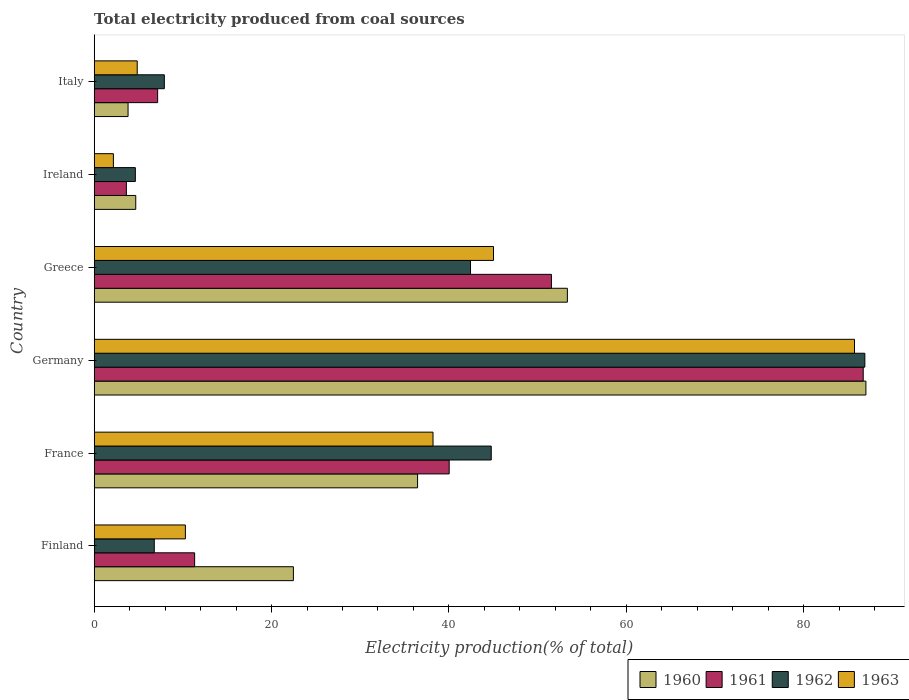Are the number of bars per tick equal to the number of legend labels?
Your answer should be very brief. Yes. How many bars are there on the 5th tick from the bottom?
Ensure brevity in your answer.  4. What is the total electricity produced in 1963 in Finland?
Your answer should be compact. 10.28. Across all countries, what is the maximum total electricity produced in 1963?
Offer a very short reply. 85.74. Across all countries, what is the minimum total electricity produced in 1961?
Make the answer very short. 3.63. In which country was the total electricity produced in 1963 minimum?
Make the answer very short. Ireland. What is the total total electricity produced in 1962 in the graph?
Ensure brevity in your answer.  193.45. What is the difference between the total electricity produced in 1960 in Finland and that in France?
Your answer should be very brief. -14. What is the difference between the total electricity produced in 1960 in Ireland and the total electricity produced in 1962 in Germany?
Offer a very short reply. -82.22. What is the average total electricity produced in 1962 per country?
Your answer should be compact. 32.24. What is the difference between the total electricity produced in 1962 and total electricity produced in 1961 in Greece?
Make the answer very short. -9.12. In how many countries, is the total electricity produced in 1960 greater than 80 %?
Make the answer very short. 1. What is the ratio of the total electricity produced in 1960 in Finland to that in Italy?
Offer a very short reply. 5.88. Is the total electricity produced in 1963 in Germany less than that in Ireland?
Provide a short and direct response. No. What is the difference between the highest and the second highest total electricity produced in 1961?
Provide a succinct answer. 35.16. What is the difference between the highest and the lowest total electricity produced in 1960?
Keep it short and to the point. 83.21. Is it the case that in every country, the sum of the total electricity produced in 1960 and total electricity produced in 1963 is greater than the total electricity produced in 1961?
Keep it short and to the point. Yes. How many bars are there?
Your answer should be compact. 24. Are all the bars in the graph horizontal?
Keep it short and to the point. Yes. Are the values on the major ticks of X-axis written in scientific E-notation?
Keep it short and to the point. No. Does the graph contain any zero values?
Keep it short and to the point. No. Does the graph contain grids?
Your answer should be very brief. No. Where does the legend appear in the graph?
Give a very brief answer. Bottom right. What is the title of the graph?
Provide a succinct answer. Total electricity produced from coal sources. Does "1976" appear as one of the legend labels in the graph?
Offer a terse response. No. What is the Electricity production(% of total) in 1960 in Finland?
Provide a succinct answer. 22.46. What is the Electricity production(% of total) in 1961 in Finland?
Offer a terse response. 11.33. What is the Electricity production(% of total) of 1962 in Finland?
Offer a terse response. 6.78. What is the Electricity production(% of total) in 1963 in Finland?
Make the answer very short. 10.28. What is the Electricity production(% of total) of 1960 in France?
Make the answer very short. 36.47. What is the Electricity production(% of total) in 1961 in France?
Provide a short and direct response. 40.03. What is the Electricity production(% of total) of 1962 in France?
Your answer should be very brief. 44.78. What is the Electricity production(% of total) of 1963 in France?
Ensure brevity in your answer.  38.21. What is the Electricity production(% of total) of 1960 in Germany?
Your response must be concise. 87.03. What is the Electricity production(% of total) in 1961 in Germany?
Provide a short and direct response. 86.73. What is the Electricity production(% of total) of 1962 in Germany?
Offer a very short reply. 86.91. What is the Electricity production(% of total) of 1963 in Germany?
Ensure brevity in your answer.  85.74. What is the Electricity production(% of total) in 1960 in Greece?
Give a very brief answer. 53.36. What is the Electricity production(% of total) in 1961 in Greece?
Offer a terse response. 51.56. What is the Electricity production(% of total) of 1962 in Greece?
Your answer should be very brief. 42.44. What is the Electricity production(% of total) in 1963 in Greece?
Your answer should be very brief. 45.03. What is the Electricity production(% of total) in 1960 in Ireland?
Offer a very short reply. 4.69. What is the Electricity production(% of total) of 1961 in Ireland?
Your response must be concise. 3.63. What is the Electricity production(% of total) in 1962 in Ireland?
Give a very brief answer. 4.64. What is the Electricity production(% of total) in 1963 in Ireland?
Offer a terse response. 2.16. What is the Electricity production(% of total) of 1960 in Italy?
Offer a very short reply. 3.82. What is the Electricity production(% of total) in 1961 in Italy?
Keep it short and to the point. 7.15. What is the Electricity production(% of total) of 1962 in Italy?
Your answer should be compact. 7.91. What is the Electricity production(% of total) in 1963 in Italy?
Provide a succinct answer. 4.85. Across all countries, what is the maximum Electricity production(% of total) of 1960?
Offer a very short reply. 87.03. Across all countries, what is the maximum Electricity production(% of total) of 1961?
Offer a terse response. 86.73. Across all countries, what is the maximum Electricity production(% of total) of 1962?
Keep it short and to the point. 86.91. Across all countries, what is the maximum Electricity production(% of total) in 1963?
Your answer should be compact. 85.74. Across all countries, what is the minimum Electricity production(% of total) in 1960?
Your answer should be compact. 3.82. Across all countries, what is the minimum Electricity production(% of total) of 1961?
Your answer should be compact. 3.63. Across all countries, what is the minimum Electricity production(% of total) of 1962?
Keep it short and to the point. 4.64. Across all countries, what is the minimum Electricity production(% of total) in 1963?
Your answer should be very brief. 2.16. What is the total Electricity production(% of total) of 1960 in the graph?
Your answer should be compact. 207.83. What is the total Electricity production(% of total) of 1961 in the graph?
Your answer should be compact. 200.43. What is the total Electricity production(% of total) in 1962 in the graph?
Give a very brief answer. 193.45. What is the total Electricity production(% of total) in 1963 in the graph?
Offer a terse response. 186.28. What is the difference between the Electricity production(% of total) of 1960 in Finland and that in France?
Provide a succinct answer. -14.01. What is the difference between the Electricity production(% of total) in 1961 in Finland and that in France?
Ensure brevity in your answer.  -28.71. What is the difference between the Electricity production(% of total) in 1962 in Finland and that in France?
Provide a succinct answer. -38. What is the difference between the Electricity production(% of total) of 1963 in Finland and that in France?
Offer a very short reply. -27.93. What is the difference between the Electricity production(% of total) in 1960 in Finland and that in Germany?
Provide a short and direct response. -64.57. What is the difference between the Electricity production(% of total) of 1961 in Finland and that in Germany?
Ensure brevity in your answer.  -75.4. What is the difference between the Electricity production(% of total) of 1962 in Finland and that in Germany?
Give a very brief answer. -80.13. What is the difference between the Electricity production(% of total) of 1963 in Finland and that in Germany?
Your answer should be very brief. -75.46. What is the difference between the Electricity production(% of total) in 1960 in Finland and that in Greece?
Provide a short and direct response. -30.9. What is the difference between the Electricity production(% of total) of 1961 in Finland and that in Greece?
Ensure brevity in your answer.  -40.24. What is the difference between the Electricity production(% of total) of 1962 in Finland and that in Greece?
Offer a very short reply. -35.66. What is the difference between the Electricity production(% of total) of 1963 in Finland and that in Greece?
Your response must be concise. -34.75. What is the difference between the Electricity production(% of total) in 1960 in Finland and that in Ireland?
Offer a very short reply. 17.78. What is the difference between the Electricity production(% of total) in 1961 in Finland and that in Ireland?
Offer a terse response. 7.7. What is the difference between the Electricity production(% of total) in 1962 in Finland and that in Ireland?
Provide a short and direct response. 2.13. What is the difference between the Electricity production(% of total) of 1963 in Finland and that in Ireland?
Provide a succinct answer. 8.12. What is the difference between the Electricity production(% of total) of 1960 in Finland and that in Italy?
Your answer should be very brief. 18.65. What is the difference between the Electricity production(% of total) of 1961 in Finland and that in Italy?
Provide a short and direct response. 4.17. What is the difference between the Electricity production(% of total) of 1962 in Finland and that in Italy?
Your answer should be very brief. -1.13. What is the difference between the Electricity production(% of total) of 1963 in Finland and that in Italy?
Your response must be concise. 5.43. What is the difference between the Electricity production(% of total) in 1960 in France and that in Germany?
Provide a succinct answer. -50.56. What is the difference between the Electricity production(% of total) in 1961 in France and that in Germany?
Ensure brevity in your answer.  -46.69. What is the difference between the Electricity production(% of total) in 1962 in France and that in Germany?
Keep it short and to the point. -42.13. What is the difference between the Electricity production(% of total) in 1963 in France and that in Germany?
Keep it short and to the point. -47.53. What is the difference between the Electricity production(% of total) in 1960 in France and that in Greece?
Your answer should be very brief. -16.89. What is the difference between the Electricity production(% of total) in 1961 in France and that in Greece?
Your answer should be compact. -11.53. What is the difference between the Electricity production(% of total) in 1962 in France and that in Greece?
Your answer should be compact. 2.34. What is the difference between the Electricity production(% of total) of 1963 in France and that in Greece?
Keep it short and to the point. -6.82. What is the difference between the Electricity production(% of total) of 1960 in France and that in Ireland?
Provide a short and direct response. 31.78. What is the difference between the Electricity production(% of total) in 1961 in France and that in Ireland?
Offer a very short reply. 36.41. What is the difference between the Electricity production(% of total) of 1962 in France and that in Ireland?
Your response must be concise. 40.14. What is the difference between the Electricity production(% of total) of 1963 in France and that in Ireland?
Ensure brevity in your answer.  36.05. What is the difference between the Electricity production(% of total) of 1960 in France and that in Italy?
Keep it short and to the point. 32.65. What is the difference between the Electricity production(% of total) in 1961 in France and that in Italy?
Your answer should be compact. 32.88. What is the difference between the Electricity production(% of total) in 1962 in France and that in Italy?
Give a very brief answer. 36.87. What is the difference between the Electricity production(% of total) in 1963 in France and that in Italy?
Your answer should be very brief. 33.36. What is the difference between the Electricity production(% of total) of 1960 in Germany and that in Greece?
Your answer should be very brief. 33.67. What is the difference between the Electricity production(% of total) in 1961 in Germany and that in Greece?
Offer a terse response. 35.16. What is the difference between the Electricity production(% of total) in 1962 in Germany and that in Greece?
Your answer should be compact. 44.47. What is the difference between the Electricity production(% of total) in 1963 in Germany and that in Greece?
Keep it short and to the point. 40.71. What is the difference between the Electricity production(% of total) in 1960 in Germany and that in Ireland?
Ensure brevity in your answer.  82.34. What is the difference between the Electricity production(% of total) in 1961 in Germany and that in Ireland?
Ensure brevity in your answer.  83.1. What is the difference between the Electricity production(% of total) of 1962 in Germany and that in Ireland?
Provide a short and direct response. 82.27. What is the difference between the Electricity production(% of total) in 1963 in Germany and that in Ireland?
Provide a short and direct response. 83.58. What is the difference between the Electricity production(% of total) in 1960 in Germany and that in Italy?
Ensure brevity in your answer.  83.21. What is the difference between the Electricity production(% of total) in 1961 in Germany and that in Italy?
Your answer should be very brief. 79.57. What is the difference between the Electricity production(% of total) of 1962 in Germany and that in Italy?
Make the answer very short. 79. What is the difference between the Electricity production(% of total) of 1963 in Germany and that in Italy?
Provide a succinct answer. 80.89. What is the difference between the Electricity production(% of total) in 1960 in Greece and that in Ireland?
Your response must be concise. 48.68. What is the difference between the Electricity production(% of total) of 1961 in Greece and that in Ireland?
Keep it short and to the point. 47.93. What is the difference between the Electricity production(% of total) in 1962 in Greece and that in Ireland?
Give a very brief answer. 37.8. What is the difference between the Electricity production(% of total) in 1963 in Greece and that in Ireland?
Offer a very short reply. 42.87. What is the difference between the Electricity production(% of total) in 1960 in Greece and that in Italy?
Your answer should be compact. 49.54. What is the difference between the Electricity production(% of total) in 1961 in Greece and that in Italy?
Give a very brief answer. 44.41. What is the difference between the Electricity production(% of total) in 1962 in Greece and that in Italy?
Your answer should be compact. 34.53. What is the difference between the Electricity production(% of total) in 1963 in Greece and that in Italy?
Your answer should be compact. 40.18. What is the difference between the Electricity production(% of total) of 1960 in Ireland and that in Italy?
Give a very brief answer. 0.87. What is the difference between the Electricity production(% of total) in 1961 in Ireland and that in Italy?
Provide a short and direct response. -3.53. What is the difference between the Electricity production(% of total) in 1962 in Ireland and that in Italy?
Offer a terse response. -3.27. What is the difference between the Electricity production(% of total) in 1963 in Ireland and that in Italy?
Offer a terse response. -2.69. What is the difference between the Electricity production(% of total) of 1960 in Finland and the Electricity production(% of total) of 1961 in France?
Your answer should be very brief. -17.57. What is the difference between the Electricity production(% of total) in 1960 in Finland and the Electricity production(% of total) in 1962 in France?
Your response must be concise. -22.31. What is the difference between the Electricity production(% of total) in 1960 in Finland and the Electricity production(% of total) in 1963 in France?
Your answer should be compact. -15.75. What is the difference between the Electricity production(% of total) in 1961 in Finland and the Electricity production(% of total) in 1962 in France?
Your response must be concise. -33.45. What is the difference between the Electricity production(% of total) of 1961 in Finland and the Electricity production(% of total) of 1963 in France?
Provide a succinct answer. -26.88. What is the difference between the Electricity production(% of total) in 1962 in Finland and the Electricity production(% of total) in 1963 in France?
Offer a very short reply. -31.44. What is the difference between the Electricity production(% of total) of 1960 in Finland and the Electricity production(% of total) of 1961 in Germany?
Offer a terse response. -64.26. What is the difference between the Electricity production(% of total) in 1960 in Finland and the Electricity production(% of total) in 1962 in Germany?
Give a very brief answer. -64.45. What is the difference between the Electricity production(% of total) in 1960 in Finland and the Electricity production(% of total) in 1963 in Germany?
Give a very brief answer. -63.28. What is the difference between the Electricity production(% of total) in 1961 in Finland and the Electricity production(% of total) in 1962 in Germany?
Provide a short and direct response. -75.58. What is the difference between the Electricity production(% of total) of 1961 in Finland and the Electricity production(% of total) of 1963 in Germany?
Your response must be concise. -74.41. What is the difference between the Electricity production(% of total) in 1962 in Finland and the Electricity production(% of total) in 1963 in Germany?
Your response must be concise. -78.97. What is the difference between the Electricity production(% of total) in 1960 in Finland and the Electricity production(% of total) in 1961 in Greece?
Your response must be concise. -29.1. What is the difference between the Electricity production(% of total) of 1960 in Finland and the Electricity production(% of total) of 1962 in Greece?
Offer a very short reply. -19.98. What is the difference between the Electricity production(% of total) in 1960 in Finland and the Electricity production(% of total) in 1963 in Greece?
Your answer should be very brief. -22.57. What is the difference between the Electricity production(% of total) of 1961 in Finland and the Electricity production(% of total) of 1962 in Greece?
Offer a terse response. -31.11. What is the difference between the Electricity production(% of total) in 1961 in Finland and the Electricity production(% of total) in 1963 in Greece?
Your answer should be very brief. -33.7. What is the difference between the Electricity production(% of total) of 1962 in Finland and the Electricity production(% of total) of 1963 in Greece?
Give a very brief answer. -38.26. What is the difference between the Electricity production(% of total) in 1960 in Finland and the Electricity production(% of total) in 1961 in Ireland?
Your answer should be very brief. 18.84. What is the difference between the Electricity production(% of total) in 1960 in Finland and the Electricity production(% of total) in 1962 in Ireland?
Your answer should be compact. 17.82. What is the difference between the Electricity production(% of total) of 1960 in Finland and the Electricity production(% of total) of 1963 in Ireland?
Give a very brief answer. 20.3. What is the difference between the Electricity production(% of total) in 1961 in Finland and the Electricity production(% of total) in 1962 in Ireland?
Your answer should be very brief. 6.69. What is the difference between the Electricity production(% of total) in 1961 in Finland and the Electricity production(% of total) in 1963 in Ireland?
Provide a short and direct response. 9.16. What is the difference between the Electricity production(% of total) in 1962 in Finland and the Electricity production(% of total) in 1963 in Ireland?
Your response must be concise. 4.61. What is the difference between the Electricity production(% of total) of 1960 in Finland and the Electricity production(% of total) of 1961 in Italy?
Your answer should be very brief. 15.31. What is the difference between the Electricity production(% of total) of 1960 in Finland and the Electricity production(% of total) of 1962 in Italy?
Make the answer very short. 14.55. What is the difference between the Electricity production(% of total) of 1960 in Finland and the Electricity production(% of total) of 1963 in Italy?
Your response must be concise. 17.61. What is the difference between the Electricity production(% of total) of 1961 in Finland and the Electricity production(% of total) of 1962 in Italy?
Ensure brevity in your answer.  3.42. What is the difference between the Electricity production(% of total) of 1961 in Finland and the Electricity production(% of total) of 1963 in Italy?
Give a very brief answer. 6.48. What is the difference between the Electricity production(% of total) in 1962 in Finland and the Electricity production(% of total) in 1963 in Italy?
Provide a succinct answer. 1.92. What is the difference between the Electricity production(% of total) in 1960 in France and the Electricity production(% of total) in 1961 in Germany?
Give a very brief answer. -50.26. What is the difference between the Electricity production(% of total) of 1960 in France and the Electricity production(% of total) of 1962 in Germany?
Your response must be concise. -50.44. What is the difference between the Electricity production(% of total) of 1960 in France and the Electricity production(% of total) of 1963 in Germany?
Ensure brevity in your answer.  -49.27. What is the difference between the Electricity production(% of total) of 1961 in France and the Electricity production(% of total) of 1962 in Germany?
Your answer should be compact. -46.87. What is the difference between the Electricity production(% of total) in 1961 in France and the Electricity production(% of total) in 1963 in Germany?
Provide a succinct answer. -45.71. What is the difference between the Electricity production(% of total) in 1962 in France and the Electricity production(% of total) in 1963 in Germany?
Keep it short and to the point. -40.97. What is the difference between the Electricity production(% of total) of 1960 in France and the Electricity production(% of total) of 1961 in Greece?
Offer a very short reply. -15.09. What is the difference between the Electricity production(% of total) in 1960 in France and the Electricity production(% of total) in 1962 in Greece?
Offer a terse response. -5.97. What is the difference between the Electricity production(% of total) in 1960 in France and the Electricity production(% of total) in 1963 in Greece?
Provide a succinct answer. -8.56. What is the difference between the Electricity production(% of total) of 1961 in France and the Electricity production(% of total) of 1962 in Greece?
Provide a succinct answer. -2.41. What is the difference between the Electricity production(% of total) in 1961 in France and the Electricity production(% of total) in 1963 in Greece?
Offer a very short reply. -5. What is the difference between the Electricity production(% of total) in 1962 in France and the Electricity production(% of total) in 1963 in Greece?
Ensure brevity in your answer.  -0.25. What is the difference between the Electricity production(% of total) of 1960 in France and the Electricity production(% of total) of 1961 in Ireland?
Provide a short and direct response. 32.84. What is the difference between the Electricity production(% of total) of 1960 in France and the Electricity production(% of total) of 1962 in Ireland?
Your response must be concise. 31.83. What is the difference between the Electricity production(% of total) of 1960 in France and the Electricity production(% of total) of 1963 in Ireland?
Your response must be concise. 34.3. What is the difference between the Electricity production(% of total) in 1961 in France and the Electricity production(% of total) in 1962 in Ireland?
Provide a short and direct response. 35.39. What is the difference between the Electricity production(% of total) of 1961 in France and the Electricity production(% of total) of 1963 in Ireland?
Ensure brevity in your answer.  37.87. What is the difference between the Electricity production(% of total) in 1962 in France and the Electricity production(% of total) in 1963 in Ireland?
Make the answer very short. 42.61. What is the difference between the Electricity production(% of total) of 1960 in France and the Electricity production(% of total) of 1961 in Italy?
Offer a terse response. 29.31. What is the difference between the Electricity production(% of total) of 1960 in France and the Electricity production(% of total) of 1962 in Italy?
Give a very brief answer. 28.56. What is the difference between the Electricity production(% of total) in 1960 in France and the Electricity production(% of total) in 1963 in Italy?
Make the answer very short. 31.62. What is the difference between the Electricity production(% of total) of 1961 in France and the Electricity production(% of total) of 1962 in Italy?
Offer a terse response. 32.13. What is the difference between the Electricity production(% of total) in 1961 in France and the Electricity production(% of total) in 1963 in Italy?
Offer a terse response. 35.18. What is the difference between the Electricity production(% of total) of 1962 in France and the Electricity production(% of total) of 1963 in Italy?
Your response must be concise. 39.93. What is the difference between the Electricity production(% of total) of 1960 in Germany and the Electricity production(% of total) of 1961 in Greece?
Make the answer very short. 35.47. What is the difference between the Electricity production(% of total) in 1960 in Germany and the Electricity production(% of total) in 1962 in Greece?
Offer a terse response. 44.59. What is the difference between the Electricity production(% of total) of 1960 in Germany and the Electricity production(% of total) of 1963 in Greece?
Keep it short and to the point. 42. What is the difference between the Electricity production(% of total) of 1961 in Germany and the Electricity production(% of total) of 1962 in Greece?
Your response must be concise. 44.29. What is the difference between the Electricity production(% of total) in 1961 in Germany and the Electricity production(% of total) in 1963 in Greece?
Provide a succinct answer. 41.69. What is the difference between the Electricity production(% of total) of 1962 in Germany and the Electricity production(% of total) of 1963 in Greece?
Provide a short and direct response. 41.88. What is the difference between the Electricity production(% of total) in 1960 in Germany and the Electricity production(% of total) in 1961 in Ireland?
Give a very brief answer. 83.4. What is the difference between the Electricity production(% of total) of 1960 in Germany and the Electricity production(% of total) of 1962 in Ireland?
Provide a short and direct response. 82.39. What is the difference between the Electricity production(% of total) in 1960 in Germany and the Electricity production(% of total) in 1963 in Ireland?
Your answer should be very brief. 84.86. What is the difference between the Electricity production(% of total) of 1961 in Germany and the Electricity production(% of total) of 1962 in Ireland?
Your answer should be compact. 82.08. What is the difference between the Electricity production(% of total) in 1961 in Germany and the Electricity production(% of total) in 1963 in Ireland?
Your answer should be compact. 84.56. What is the difference between the Electricity production(% of total) in 1962 in Germany and the Electricity production(% of total) in 1963 in Ireland?
Your response must be concise. 84.74. What is the difference between the Electricity production(% of total) in 1960 in Germany and the Electricity production(% of total) in 1961 in Italy?
Give a very brief answer. 79.87. What is the difference between the Electricity production(% of total) of 1960 in Germany and the Electricity production(% of total) of 1962 in Italy?
Offer a terse response. 79.12. What is the difference between the Electricity production(% of total) of 1960 in Germany and the Electricity production(% of total) of 1963 in Italy?
Ensure brevity in your answer.  82.18. What is the difference between the Electricity production(% of total) in 1961 in Germany and the Electricity production(% of total) in 1962 in Italy?
Your response must be concise. 78.82. What is the difference between the Electricity production(% of total) in 1961 in Germany and the Electricity production(% of total) in 1963 in Italy?
Offer a very short reply. 81.87. What is the difference between the Electricity production(% of total) in 1962 in Germany and the Electricity production(% of total) in 1963 in Italy?
Provide a short and direct response. 82.06. What is the difference between the Electricity production(% of total) of 1960 in Greece and the Electricity production(% of total) of 1961 in Ireland?
Provide a succinct answer. 49.73. What is the difference between the Electricity production(% of total) in 1960 in Greece and the Electricity production(% of total) in 1962 in Ireland?
Make the answer very short. 48.72. What is the difference between the Electricity production(% of total) of 1960 in Greece and the Electricity production(% of total) of 1963 in Ireland?
Provide a short and direct response. 51.2. What is the difference between the Electricity production(% of total) of 1961 in Greece and the Electricity production(% of total) of 1962 in Ireland?
Keep it short and to the point. 46.92. What is the difference between the Electricity production(% of total) in 1961 in Greece and the Electricity production(% of total) in 1963 in Ireland?
Your answer should be very brief. 49.4. What is the difference between the Electricity production(% of total) of 1962 in Greece and the Electricity production(% of total) of 1963 in Ireland?
Provide a short and direct response. 40.27. What is the difference between the Electricity production(% of total) in 1960 in Greece and the Electricity production(% of total) in 1961 in Italy?
Make the answer very short. 46.21. What is the difference between the Electricity production(% of total) of 1960 in Greece and the Electricity production(% of total) of 1962 in Italy?
Keep it short and to the point. 45.45. What is the difference between the Electricity production(% of total) of 1960 in Greece and the Electricity production(% of total) of 1963 in Italy?
Your response must be concise. 48.51. What is the difference between the Electricity production(% of total) in 1961 in Greece and the Electricity production(% of total) in 1962 in Italy?
Give a very brief answer. 43.65. What is the difference between the Electricity production(% of total) of 1961 in Greece and the Electricity production(% of total) of 1963 in Italy?
Ensure brevity in your answer.  46.71. What is the difference between the Electricity production(% of total) in 1962 in Greece and the Electricity production(% of total) in 1963 in Italy?
Make the answer very short. 37.59. What is the difference between the Electricity production(% of total) in 1960 in Ireland and the Electricity production(% of total) in 1961 in Italy?
Your response must be concise. -2.47. What is the difference between the Electricity production(% of total) of 1960 in Ireland and the Electricity production(% of total) of 1962 in Italy?
Your response must be concise. -3.22. What is the difference between the Electricity production(% of total) in 1960 in Ireland and the Electricity production(% of total) in 1963 in Italy?
Your response must be concise. -0.17. What is the difference between the Electricity production(% of total) in 1961 in Ireland and the Electricity production(% of total) in 1962 in Italy?
Give a very brief answer. -4.28. What is the difference between the Electricity production(% of total) in 1961 in Ireland and the Electricity production(% of total) in 1963 in Italy?
Give a very brief answer. -1.22. What is the difference between the Electricity production(% of total) in 1962 in Ireland and the Electricity production(% of total) in 1963 in Italy?
Ensure brevity in your answer.  -0.21. What is the average Electricity production(% of total) of 1960 per country?
Make the answer very short. 34.64. What is the average Electricity production(% of total) of 1961 per country?
Make the answer very short. 33.41. What is the average Electricity production(% of total) in 1962 per country?
Provide a succinct answer. 32.24. What is the average Electricity production(% of total) in 1963 per country?
Your answer should be compact. 31.05. What is the difference between the Electricity production(% of total) in 1960 and Electricity production(% of total) in 1961 in Finland?
Your response must be concise. 11.14. What is the difference between the Electricity production(% of total) in 1960 and Electricity production(% of total) in 1962 in Finland?
Make the answer very short. 15.69. What is the difference between the Electricity production(% of total) of 1960 and Electricity production(% of total) of 1963 in Finland?
Provide a succinct answer. 12.18. What is the difference between the Electricity production(% of total) of 1961 and Electricity production(% of total) of 1962 in Finland?
Provide a succinct answer. 4.55. What is the difference between the Electricity production(% of total) of 1961 and Electricity production(% of total) of 1963 in Finland?
Your answer should be compact. 1.04. What is the difference between the Electricity production(% of total) of 1962 and Electricity production(% of total) of 1963 in Finland?
Keep it short and to the point. -3.51. What is the difference between the Electricity production(% of total) of 1960 and Electricity production(% of total) of 1961 in France?
Keep it short and to the point. -3.57. What is the difference between the Electricity production(% of total) in 1960 and Electricity production(% of total) in 1962 in France?
Provide a succinct answer. -8.31. What is the difference between the Electricity production(% of total) of 1960 and Electricity production(% of total) of 1963 in France?
Keep it short and to the point. -1.74. What is the difference between the Electricity production(% of total) of 1961 and Electricity production(% of total) of 1962 in France?
Keep it short and to the point. -4.74. What is the difference between the Electricity production(% of total) of 1961 and Electricity production(% of total) of 1963 in France?
Ensure brevity in your answer.  1.82. What is the difference between the Electricity production(% of total) of 1962 and Electricity production(% of total) of 1963 in France?
Make the answer very short. 6.57. What is the difference between the Electricity production(% of total) of 1960 and Electricity production(% of total) of 1961 in Germany?
Your answer should be very brief. 0.3. What is the difference between the Electricity production(% of total) in 1960 and Electricity production(% of total) in 1962 in Germany?
Ensure brevity in your answer.  0.12. What is the difference between the Electricity production(% of total) of 1960 and Electricity production(% of total) of 1963 in Germany?
Offer a very short reply. 1.29. What is the difference between the Electricity production(% of total) in 1961 and Electricity production(% of total) in 1962 in Germany?
Your answer should be compact. -0.18. What is the difference between the Electricity production(% of total) of 1961 and Electricity production(% of total) of 1963 in Germany?
Make the answer very short. 0.98. What is the difference between the Electricity production(% of total) of 1962 and Electricity production(% of total) of 1963 in Germany?
Ensure brevity in your answer.  1.17. What is the difference between the Electricity production(% of total) of 1960 and Electricity production(% of total) of 1961 in Greece?
Ensure brevity in your answer.  1.8. What is the difference between the Electricity production(% of total) in 1960 and Electricity production(% of total) in 1962 in Greece?
Make the answer very short. 10.92. What is the difference between the Electricity production(% of total) of 1960 and Electricity production(% of total) of 1963 in Greece?
Provide a short and direct response. 8.33. What is the difference between the Electricity production(% of total) of 1961 and Electricity production(% of total) of 1962 in Greece?
Offer a very short reply. 9.12. What is the difference between the Electricity production(% of total) of 1961 and Electricity production(% of total) of 1963 in Greece?
Make the answer very short. 6.53. What is the difference between the Electricity production(% of total) of 1962 and Electricity production(% of total) of 1963 in Greece?
Ensure brevity in your answer.  -2.59. What is the difference between the Electricity production(% of total) of 1960 and Electricity production(% of total) of 1961 in Ireland?
Offer a very short reply. 1.06. What is the difference between the Electricity production(% of total) in 1960 and Electricity production(% of total) in 1962 in Ireland?
Keep it short and to the point. 0.05. What is the difference between the Electricity production(% of total) in 1960 and Electricity production(% of total) in 1963 in Ireland?
Your response must be concise. 2.52. What is the difference between the Electricity production(% of total) in 1961 and Electricity production(% of total) in 1962 in Ireland?
Your response must be concise. -1.01. What is the difference between the Electricity production(% of total) of 1961 and Electricity production(% of total) of 1963 in Ireland?
Offer a terse response. 1.46. What is the difference between the Electricity production(% of total) of 1962 and Electricity production(% of total) of 1963 in Ireland?
Provide a short and direct response. 2.48. What is the difference between the Electricity production(% of total) in 1960 and Electricity production(% of total) in 1961 in Italy?
Your response must be concise. -3.34. What is the difference between the Electricity production(% of total) of 1960 and Electricity production(% of total) of 1962 in Italy?
Make the answer very short. -4.09. What is the difference between the Electricity production(% of total) of 1960 and Electricity production(% of total) of 1963 in Italy?
Your answer should be very brief. -1.03. What is the difference between the Electricity production(% of total) in 1961 and Electricity production(% of total) in 1962 in Italy?
Provide a short and direct response. -0.75. What is the difference between the Electricity production(% of total) in 1961 and Electricity production(% of total) in 1963 in Italy?
Offer a very short reply. 2.3. What is the difference between the Electricity production(% of total) in 1962 and Electricity production(% of total) in 1963 in Italy?
Your response must be concise. 3.06. What is the ratio of the Electricity production(% of total) of 1960 in Finland to that in France?
Make the answer very short. 0.62. What is the ratio of the Electricity production(% of total) in 1961 in Finland to that in France?
Your response must be concise. 0.28. What is the ratio of the Electricity production(% of total) of 1962 in Finland to that in France?
Provide a succinct answer. 0.15. What is the ratio of the Electricity production(% of total) of 1963 in Finland to that in France?
Your answer should be very brief. 0.27. What is the ratio of the Electricity production(% of total) in 1960 in Finland to that in Germany?
Make the answer very short. 0.26. What is the ratio of the Electricity production(% of total) of 1961 in Finland to that in Germany?
Make the answer very short. 0.13. What is the ratio of the Electricity production(% of total) of 1962 in Finland to that in Germany?
Provide a succinct answer. 0.08. What is the ratio of the Electricity production(% of total) of 1963 in Finland to that in Germany?
Offer a terse response. 0.12. What is the ratio of the Electricity production(% of total) of 1960 in Finland to that in Greece?
Offer a terse response. 0.42. What is the ratio of the Electricity production(% of total) in 1961 in Finland to that in Greece?
Make the answer very short. 0.22. What is the ratio of the Electricity production(% of total) of 1962 in Finland to that in Greece?
Offer a terse response. 0.16. What is the ratio of the Electricity production(% of total) of 1963 in Finland to that in Greece?
Provide a succinct answer. 0.23. What is the ratio of the Electricity production(% of total) in 1960 in Finland to that in Ireland?
Provide a succinct answer. 4.79. What is the ratio of the Electricity production(% of total) in 1961 in Finland to that in Ireland?
Provide a short and direct response. 3.12. What is the ratio of the Electricity production(% of total) in 1962 in Finland to that in Ireland?
Your response must be concise. 1.46. What is the ratio of the Electricity production(% of total) in 1963 in Finland to that in Ireland?
Keep it short and to the point. 4.75. What is the ratio of the Electricity production(% of total) in 1960 in Finland to that in Italy?
Keep it short and to the point. 5.88. What is the ratio of the Electricity production(% of total) in 1961 in Finland to that in Italy?
Offer a very short reply. 1.58. What is the ratio of the Electricity production(% of total) of 1962 in Finland to that in Italy?
Keep it short and to the point. 0.86. What is the ratio of the Electricity production(% of total) in 1963 in Finland to that in Italy?
Your answer should be very brief. 2.12. What is the ratio of the Electricity production(% of total) in 1960 in France to that in Germany?
Your response must be concise. 0.42. What is the ratio of the Electricity production(% of total) in 1961 in France to that in Germany?
Your response must be concise. 0.46. What is the ratio of the Electricity production(% of total) in 1962 in France to that in Germany?
Offer a terse response. 0.52. What is the ratio of the Electricity production(% of total) in 1963 in France to that in Germany?
Ensure brevity in your answer.  0.45. What is the ratio of the Electricity production(% of total) of 1960 in France to that in Greece?
Your response must be concise. 0.68. What is the ratio of the Electricity production(% of total) of 1961 in France to that in Greece?
Offer a very short reply. 0.78. What is the ratio of the Electricity production(% of total) of 1962 in France to that in Greece?
Offer a very short reply. 1.06. What is the ratio of the Electricity production(% of total) of 1963 in France to that in Greece?
Provide a short and direct response. 0.85. What is the ratio of the Electricity production(% of total) in 1960 in France to that in Ireland?
Provide a short and direct response. 7.78. What is the ratio of the Electricity production(% of total) of 1961 in France to that in Ireland?
Your answer should be very brief. 11.03. What is the ratio of the Electricity production(% of total) in 1962 in France to that in Ireland?
Provide a short and direct response. 9.65. What is the ratio of the Electricity production(% of total) of 1963 in France to that in Ireland?
Your answer should be compact. 17.65. What is the ratio of the Electricity production(% of total) in 1960 in France to that in Italy?
Your answer should be very brief. 9.55. What is the ratio of the Electricity production(% of total) in 1961 in France to that in Italy?
Make the answer very short. 5.6. What is the ratio of the Electricity production(% of total) of 1962 in France to that in Italy?
Make the answer very short. 5.66. What is the ratio of the Electricity production(% of total) of 1963 in France to that in Italy?
Offer a very short reply. 7.88. What is the ratio of the Electricity production(% of total) of 1960 in Germany to that in Greece?
Offer a very short reply. 1.63. What is the ratio of the Electricity production(% of total) in 1961 in Germany to that in Greece?
Offer a very short reply. 1.68. What is the ratio of the Electricity production(% of total) of 1962 in Germany to that in Greece?
Offer a very short reply. 2.05. What is the ratio of the Electricity production(% of total) in 1963 in Germany to that in Greece?
Provide a succinct answer. 1.9. What is the ratio of the Electricity production(% of total) in 1960 in Germany to that in Ireland?
Provide a short and direct response. 18.57. What is the ratio of the Electricity production(% of total) of 1961 in Germany to that in Ireland?
Provide a short and direct response. 23.9. What is the ratio of the Electricity production(% of total) of 1962 in Germany to that in Ireland?
Provide a short and direct response. 18.73. What is the ratio of the Electricity production(% of total) in 1963 in Germany to that in Ireland?
Give a very brief answer. 39.6. What is the ratio of the Electricity production(% of total) of 1960 in Germany to that in Italy?
Your response must be concise. 22.79. What is the ratio of the Electricity production(% of total) of 1961 in Germany to that in Italy?
Provide a short and direct response. 12.12. What is the ratio of the Electricity production(% of total) in 1962 in Germany to that in Italy?
Provide a succinct answer. 10.99. What is the ratio of the Electricity production(% of total) of 1963 in Germany to that in Italy?
Provide a short and direct response. 17.67. What is the ratio of the Electricity production(% of total) in 1960 in Greece to that in Ireland?
Offer a very short reply. 11.39. What is the ratio of the Electricity production(% of total) of 1961 in Greece to that in Ireland?
Give a very brief answer. 14.21. What is the ratio of the Electricity production(% of total) in 1962 in Greece to that in Ireland?
Provide a succinct answer. 9.14. What is the ratio of the Electricity production(% of total) of 1963 in Greece to that in Ireland?
Your answer should be very brief. 20.8. What is the ratio of the Electricity production(% of total) of 1960 in Greece to that in Italy?
Keep it short and to the point. 13.97. What is the ratio of the Electricity production(% of total) in 1961 in Greece to that in Italy?
Ensure brevity in your answer.  7.21. What is the ratio of the Electricity production(% of total) of 1962 in Greece to that in Italy?
Make the answer very short. 5.37. What is the ratio of the Electricity production(% of total) in 1963 in Greece to that in Italy?
Your answer should be compact. 9.28. What is the ratio of the Electricity production(% of total) in 1960 in Ireland to that in Italy?
Your answer should be compact. 1.23. What is the ratio of the Electricity production(% of total) of 1961 in Ireland to that in Italy?
Keep it short and to the point. 0.51. What is the ratio of the Electricity production(% of total) in 1962 in Ireland to that in Italy?
Provide a succinct answer. 0.59. What is the ratio of the Electricity production(% of total) of 1963 in Ireland to that in Italy?
Make the answer very short. 0.45. What is the difference between the highest and the second highest Electricity production(% of total) in 1960?
Give a very brief answer. 33.67. What is the difference between the highest and the second highest Electricity production(% of total) in 1961?
Your response must be concise. 35.16. What is the difference between the highest and the second highest Electricity production(% of total) of 1962?
Provide a succinct answer. 42.13. What is the difference between the highest and the second highest Electricity production(% of total) of 1963?
Keep it short and to the point. 40.71. What is the difference between the highest and the lowest Electricity production(% of total) in 1960?
Ensure brevity in your answer.  83.21. What is the difference between the highest and the lowest Electricity production(% of total) in 1961?
Keep it short and to the point. 83.1. What is the difference between the highest and the lowest Electricity production(% of total) of 1962?
Your answer should be compact. 82.27. What is the difference between the highest and the lowest Electricity production(% of total) of 1963?
Ensure brevity in your answer.  83.58. 